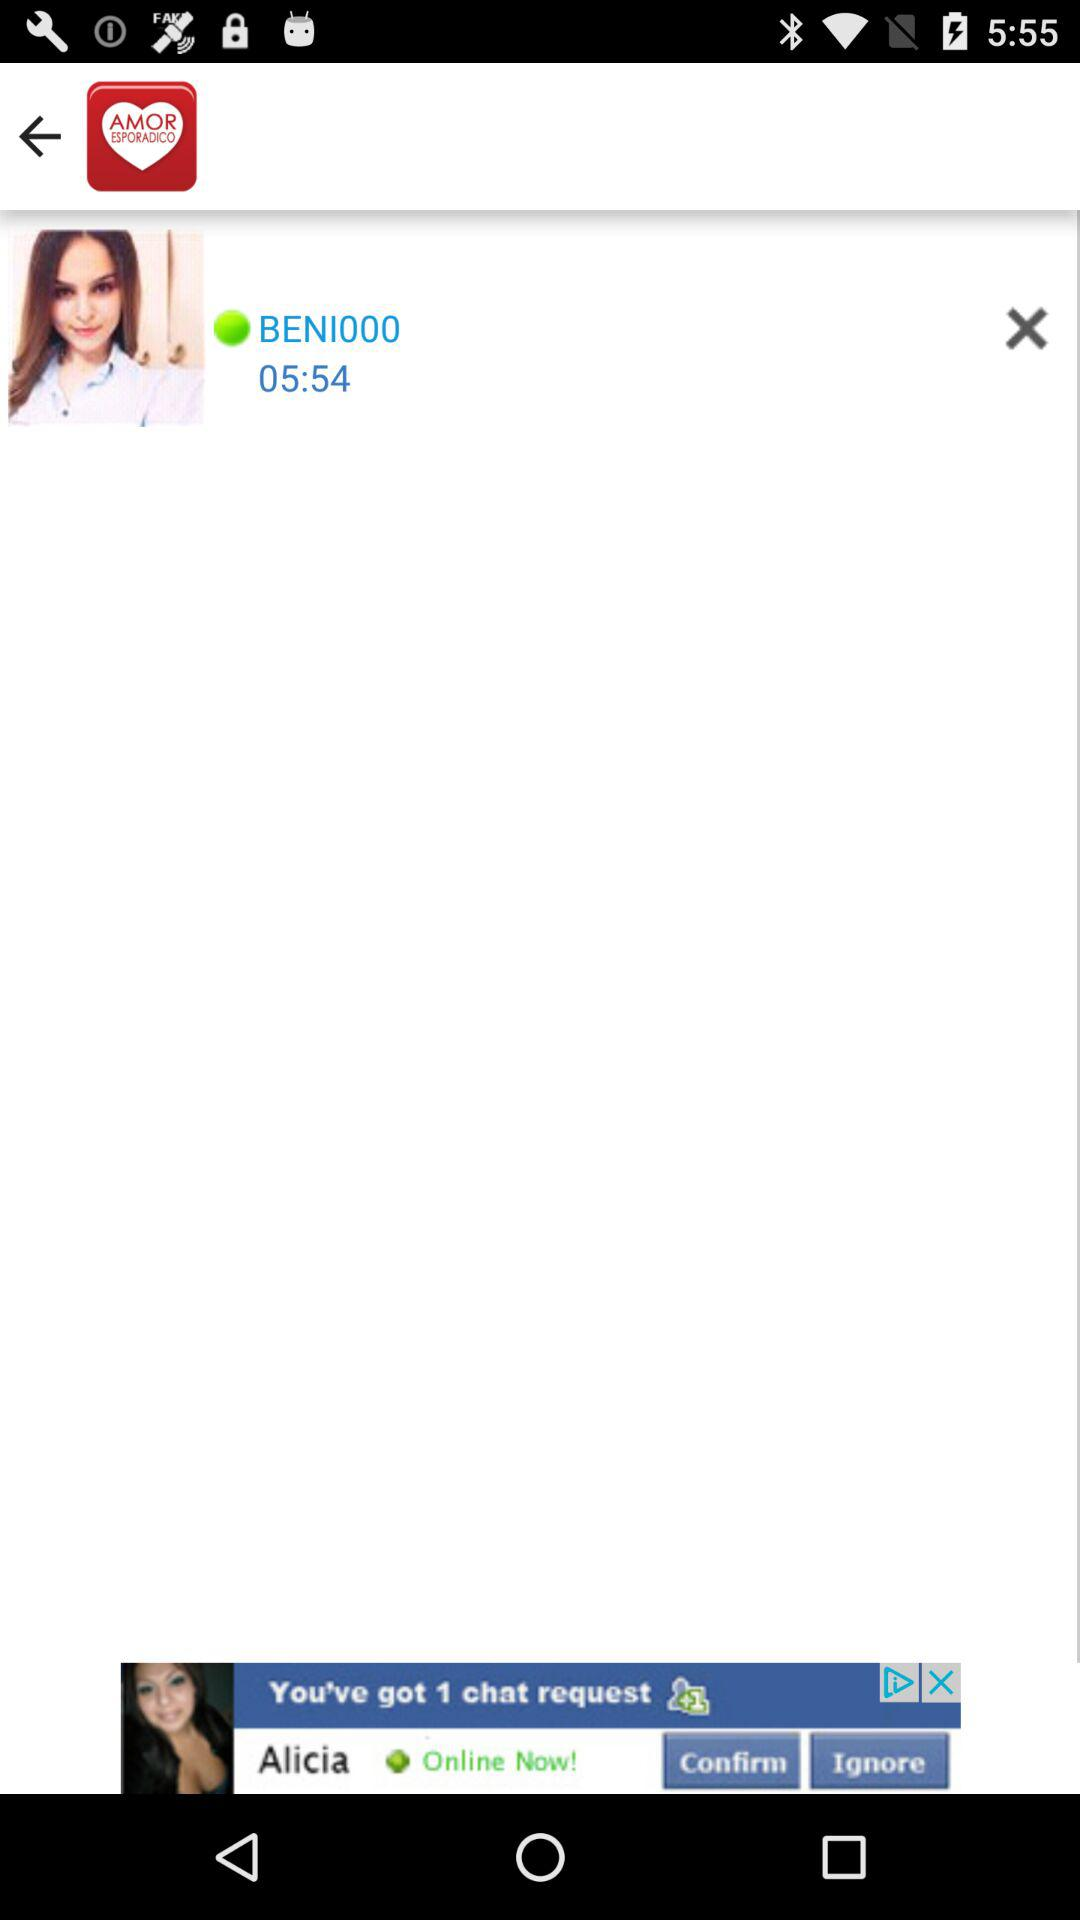What version of the application is being used?
When the provided information is insufficient, respond with <no answer>. <no answer> 